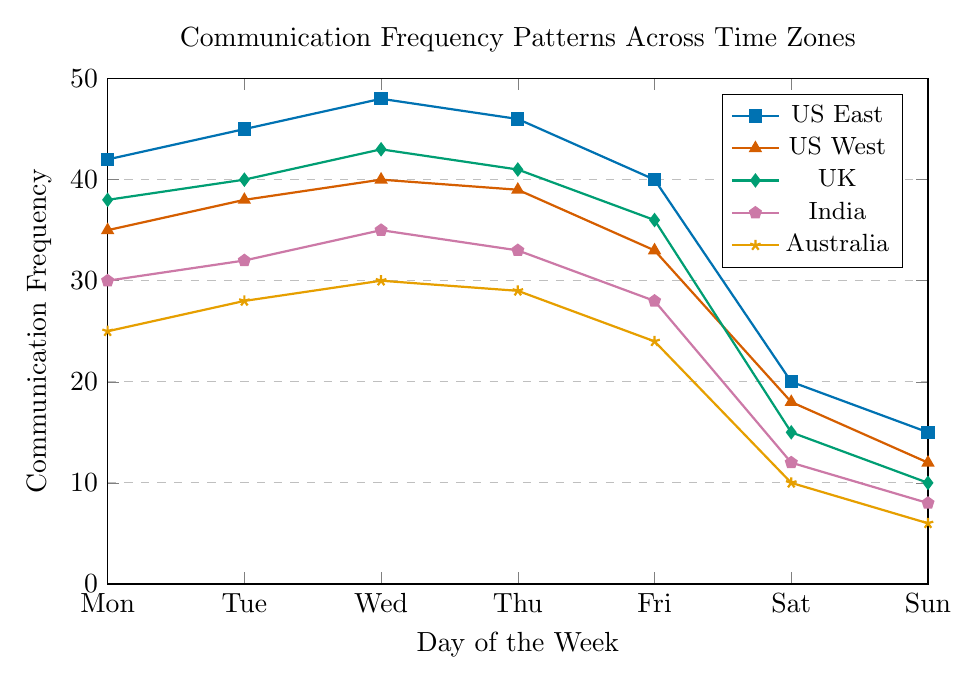What's the highest communication frequency observed in the figure? Look for the highest point on the y-axis across all lines. The highest point is 48 on Wednesday for US East.
Answer: 48 On which day does the UK have the same communication frequency as US East on Friday? Identify the communication frequency of US East on Friday, which is 40. Find where the UK line intersects 40, which is on Tuesday.
Answer: Tuesday What's the difference in communication frequency between US East and India on Wednesday? US East has a communication frequency of 48 on Wednesday, while India has 35. Calculate the difference: 48 - 35 = 13.
Answer: 13 Which time zone has the lowest communication frequency on Sunday? Observe the communication frequencies for all time zones on Sunday. Australia has the lowest value at 6.
Answer: Australia What is the average communication frequency for Australia from Monday to Friday? Sum the values from Monday to Friday for Australia: 25 + 28 + 30 + 29 + 24 = 136. Divide by the number of days (5): 136/5 = 27.2.
Answer: 27.2 How do the communication frequencies for US West and UK on Thursday compare? On Thursday, US West has 39 and UK has 41. Compare the values: US West < UK.
Answer: UK is higher Which two time zones have equal communication frequencies on any day, and what is that day and frequency? Look for intersecting points. India and UK both have 35 on Wednesday.
Answer: India and UK, Wednesday, 35 Which time zone shows a constant pattern in communication from Saturday to Sunday? Observe the change from Saturday to Sunday. All time zones decline, but US East and UK lower consistently. However, "constant" interprets equally spaced, which none show here from Saturday to Sunday precisely.
Answer: None What is the total communication frequency for US East over the weekend (Saturday and Sunday)? Sum the values for US East on Saturday and Sunday: 20 + 15 = 35.
Answer: 35 How does the trend of communication frequency during the weekdays compare for US East and India? Both US East and India show an initial increase from Monday to Wednesday, followed by a slight drop on Thursday and a more significant drop on Friday.
Answer: Similar trend with Monday-Wednesday rise and Thursday-Friday fall 